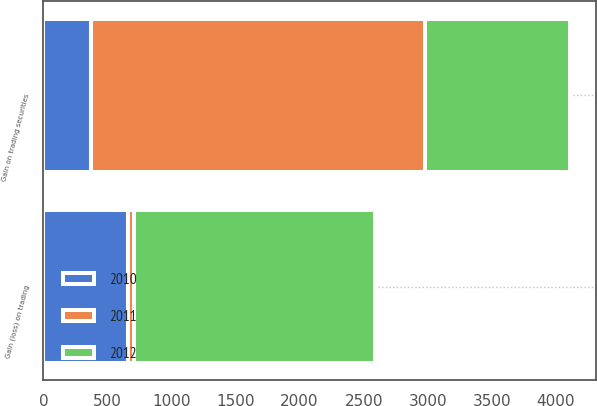<chart> <loc_0><loc_0><loc_500><loc_500><stacked_bar_chart><ecel><fcel>Gain on trading securities<fcel>Gain (loss) on trading<nl><fcel>2012<fcel>1130<fcel>1883<nl><fcel>2011<fcel>2604<fcel>44<nl><fcel>2010<fcel>375<fcel>662.5<nl></chart> 